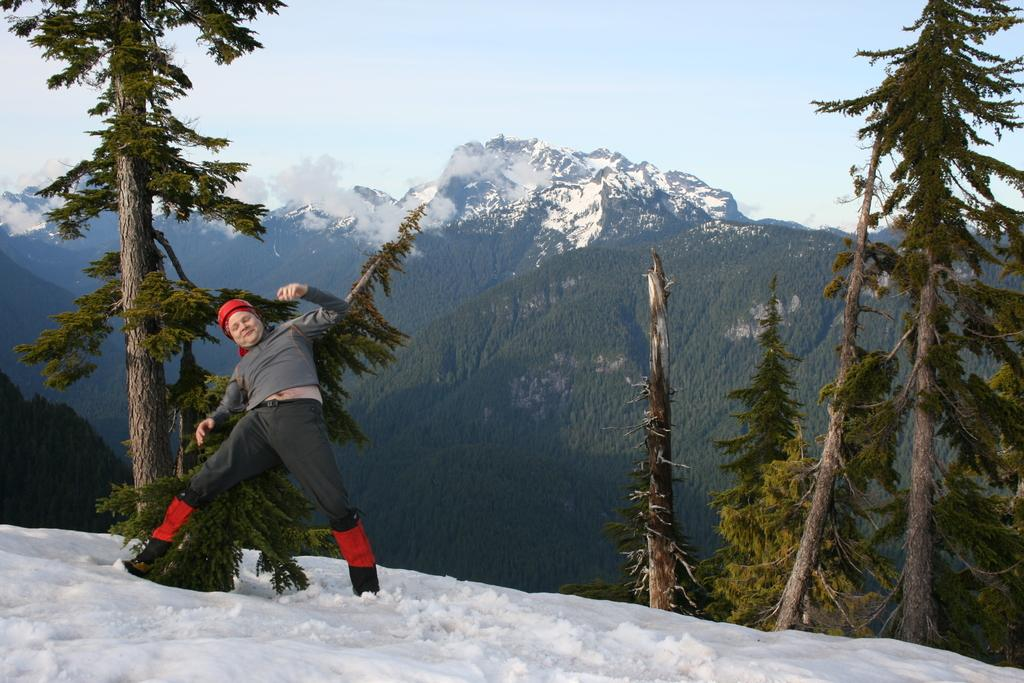What is located on the left side of the image? There is a man on the left side of the image. What type of clothing is the man wearing on his upper body? The man is wearing a t-shirt. What type of clothing is the man wearing on his lower body? The man is wearing trousers. What type of headwear is the man wearing? The man is wearing a cap. What is present at the bottom of the image? There is ice at the bottom of the image. What type of natural features can be seen in the background of the image? There are trees, mountains, and clouds in the background of the image. What part of the sky is visible in the background of the image? The sky is visible in the background of the image. What type of street can be seen in the image? There is no street present in the image. What type of land is visible in the image? The image does not specifically show land; it features a man, ice, and natural features in the background. 